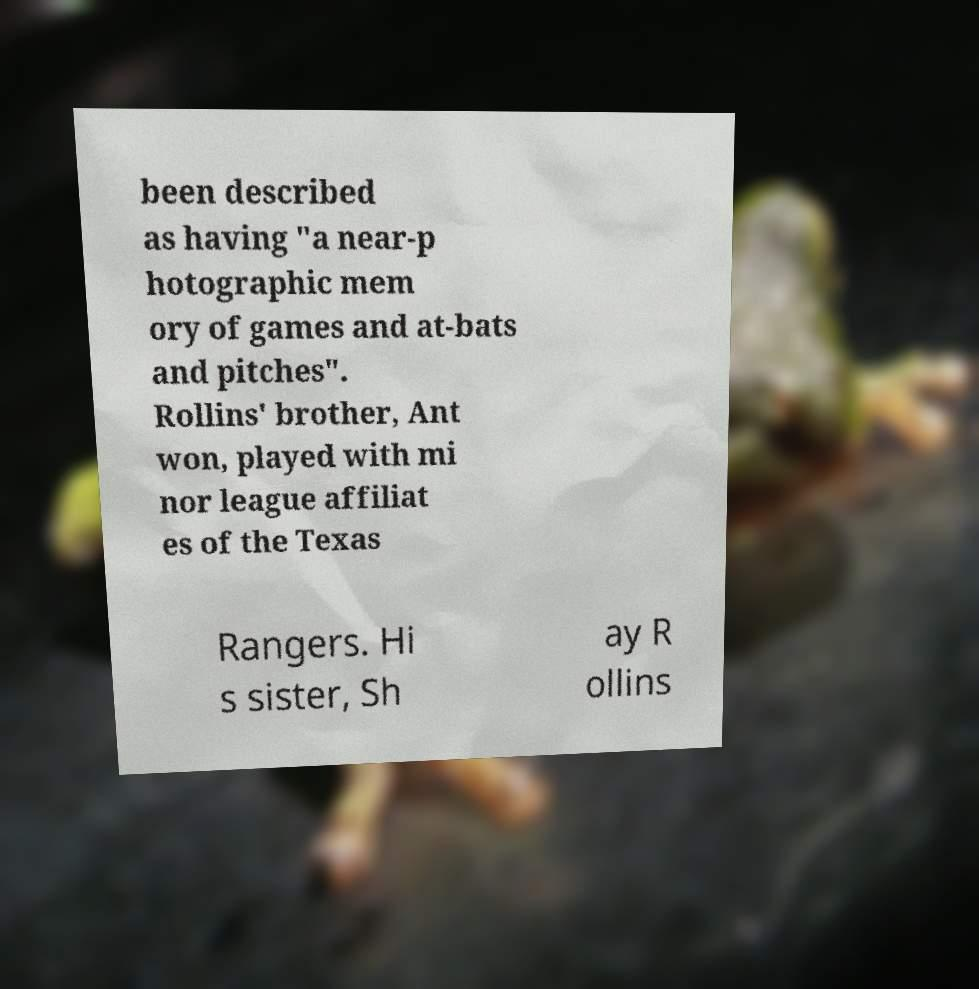I need the written content from this picture converted into text. Can you do that? been described as having "a near-p hotographic mem ory of games and at-bats and pitches". Rollins' brother, Ant won, played with mi nor league affiliat es of the Texas Rangers. Hi s sister, Sh ay R ollins 